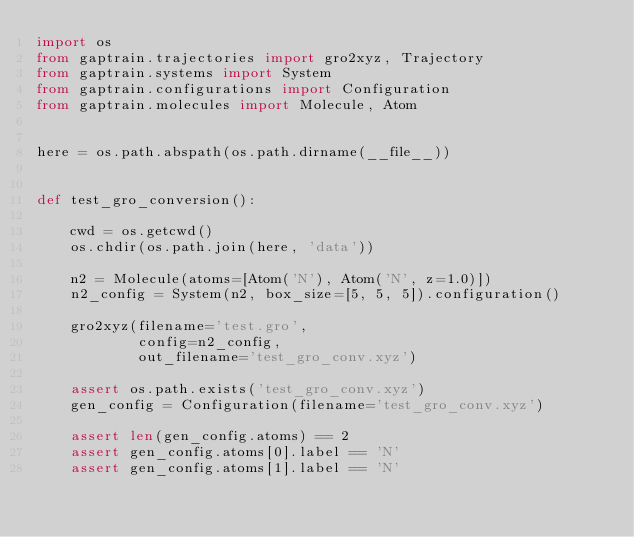<code> <loc_0><loc_0><loc_500><loc_500><_Python_>import os
from gaptrain.trajectories import gro2xyz, Trajectory
from gaptrain.systems import System
from gaptrain.configurations import Configuration
from gaptrain.molecules import Molecule, Atom


here = os.path.abspath(os.path.dirname(__file__))


def test_gro_conversion():

    cwd = os.getcwd()
    os.chdir(os.path.join(here, 'data'))

    n2 = Molecule(atoms=[Atom('N'), Atom('N', z=1.0)])
    n2_config = System(n2, box_size=[5, 5, 5]).configuration()

    gro2xyz(filename='test.gro',
            config=n2_config,
            out_filename='test_gro_conv.xyz')

    assert os.path.exists('test_gro_conv.xyz')
    gen_config = Configuration(filename='test_gro_conv.xyz')

    assert len(gen_config.atoms) == 2
    assert gen_config.atoms[0].label == 'N'
    assert gen_config.atoms[1].label == 'N'</code> 